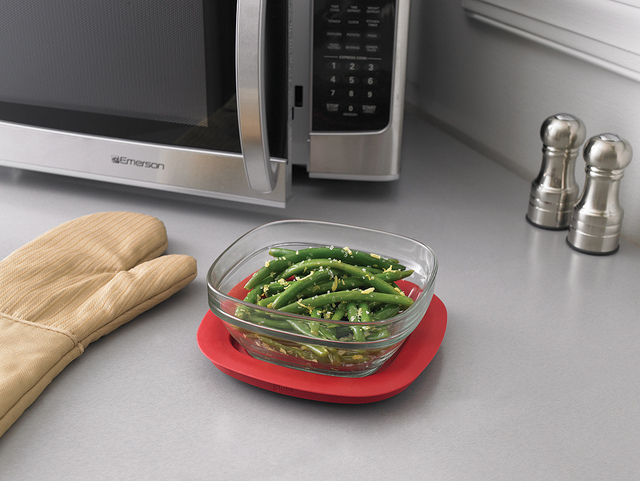What is the red item under the bowl? The red item under the clear glass bowl is a flexible, heat-resistant silicone pot holder, commonly used to provide a non-slip surface and heat insulation. 